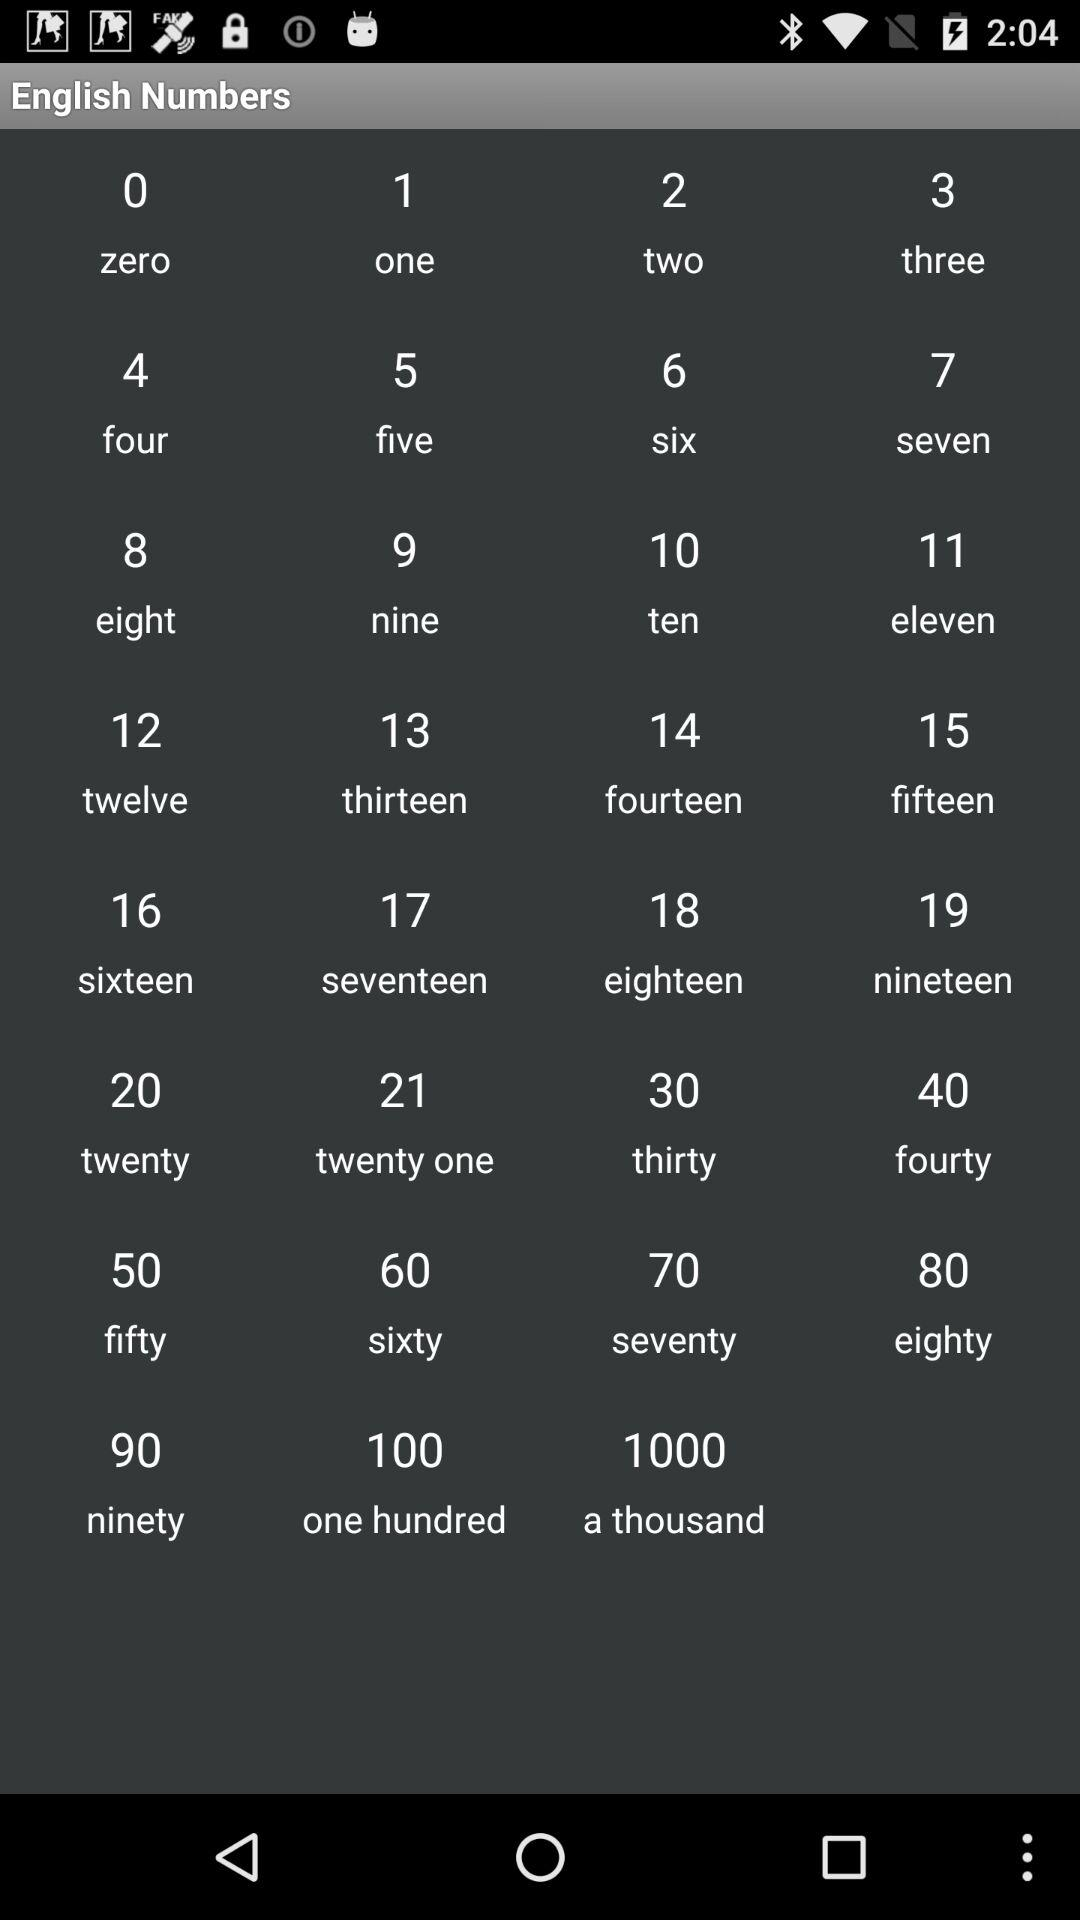Which number is greater, 90 or 100?
Answer the question using a single word or phrase. 100 